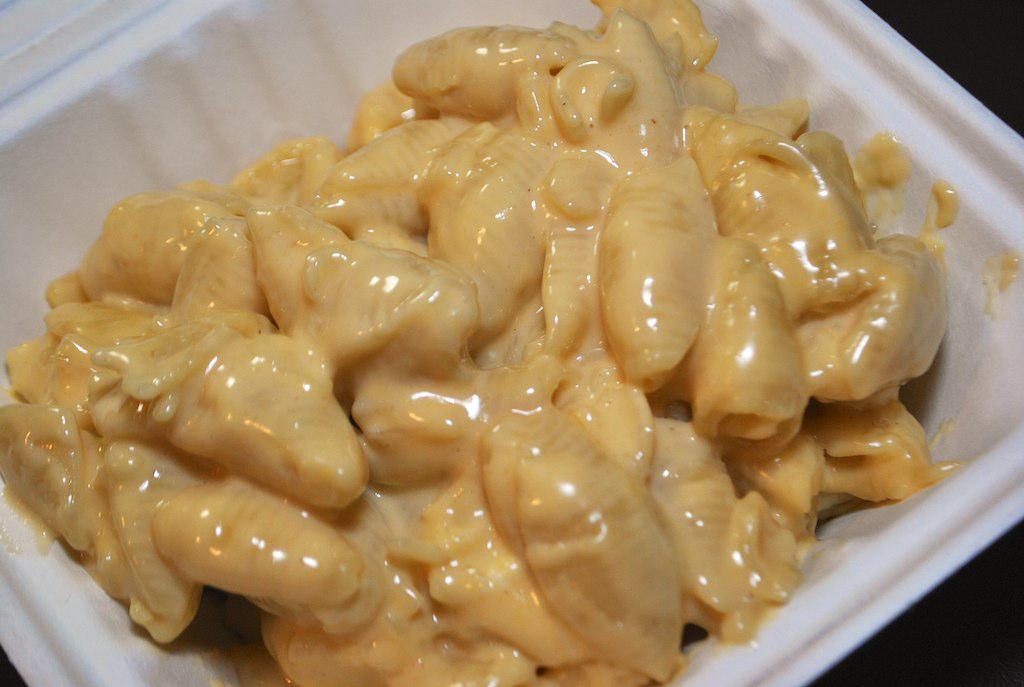How would you summarize this image in a sentence or two? In this picture we can see some eatable thing placed in a bowl. 